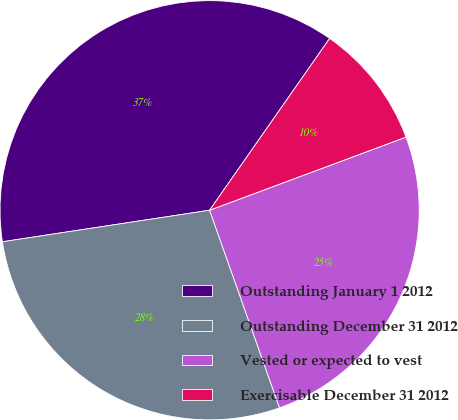<chart> <loc_0><loc_0><loc_500><loc_500><pie_chart><fcel>Outstanding January 1 2012<fcel>Outstanding December 31 2012<fcel>Vested or expected to vest<fcel>Exercisable December 31 2012<nl><fcel>37.11%<fcel>28.01%<fcel>25.26%<fcel>9.62%<nl></chart> 